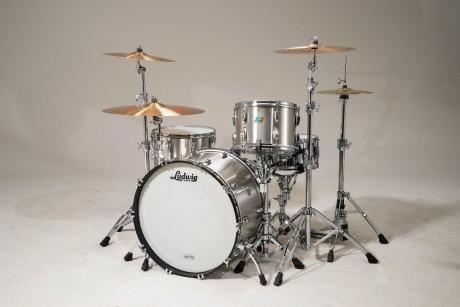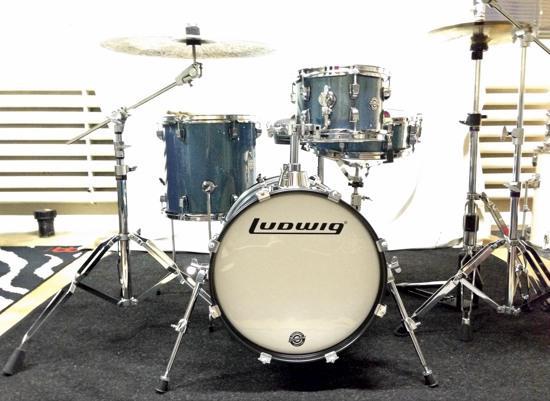The first image is the image on the left, the second image is the image on the right. Given the left and right images, does the statement "At least one drum kit is silver colored." hold true? Answer yes or no. Yes. The first image is the image on the left, the second image is the image on the right. Assess this claim about the two images: "Each image shows a drum kit, but only one image features a drum kit with at least one black-faced drum that is turned on its side.". Correct or not? Answer yes or no. No. 